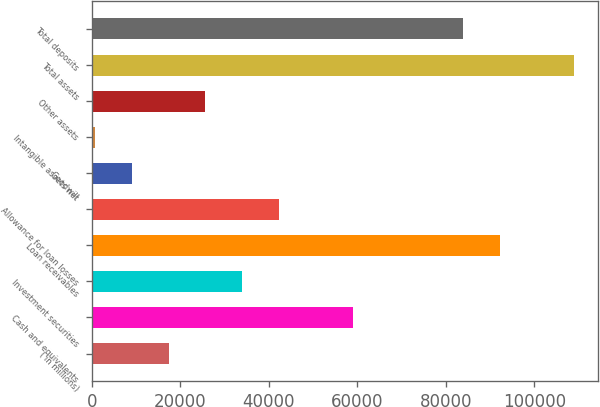Convert chart. <chart><loc_0><loc_0><loc_500><loc_500><bar_chart><fcel>( in millions)<fcel>Cash and equivalents<fcel>Investment securities<fcel>Loan receivables<fcel>Allowance for loan losses<fcel>Goodwill<fcel>Intangible assets net<fcel>Other assets<fcel>Total assets<fcel>Total deposits<nl><fcel>17358.8<fcel>59003.3<fcel>34016.6<fcel>92318.9<fcel>42345.5<fcel>9029.9<fcel>701<fcel>25687.7<fcel>108977<fcel>83990<nl></chart> 